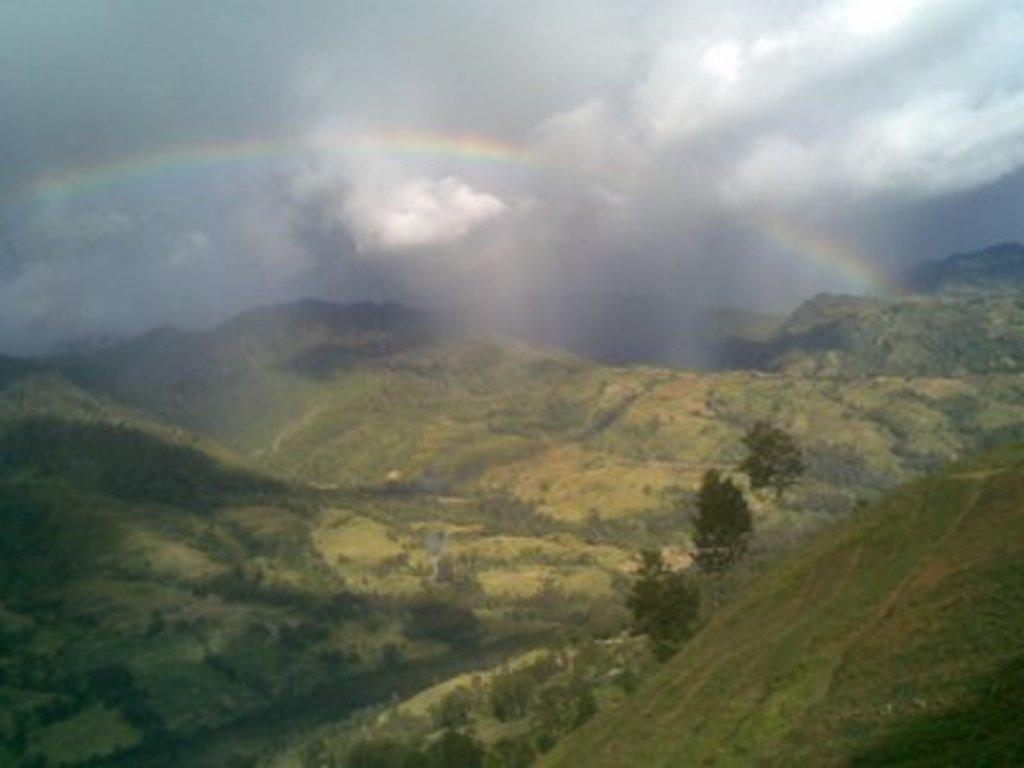What type of vegetation can be seen in the image? There are trees and grass in the image. What type of natural landform is visible in the image? There are mountains in the image. What is visible in the background of the image? The sky is visible in the background of the image. What is the weather like in the image? The sky is cloudy, which suggests it might be overcast or rainy. What additional feature can be seen in the background of the image? There is a rainbow in the background of the image. How many fish can be seen swimming in the grass in the image? There are no fish present in the image, as it features trees, grass, mountains, and a sky with a rainbow. What type of soap is being used to clean the trees in the image? There is no soap or cleaning activity depicted in the image; it focuses on natural elements and a rainbow. 